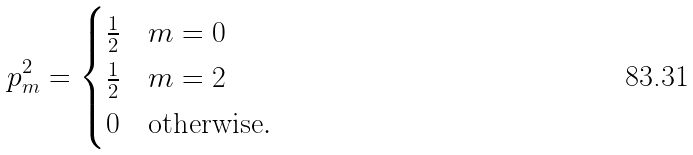Convert formula to latex. <formula><loc_0><loc_0><loc_500><loc_500>p _ { m } ^ { 2 } = \begin{cases} \frac { 1 } { 2 } & m = 0 \\ \frac { 1 } { 2 } & m = 2 \\ 0 & \text {otherwise} . \end{cases}</formula> 